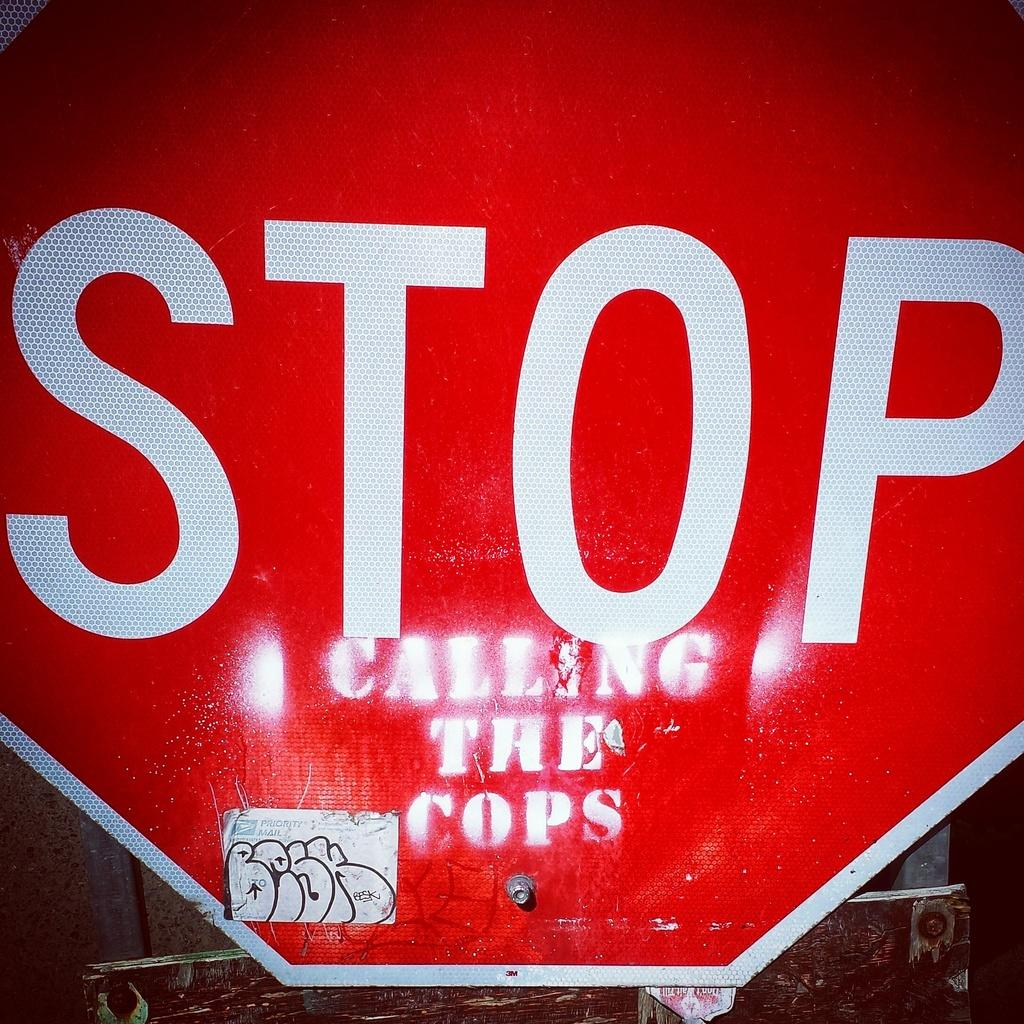<image>
Share a concise interpretation of the image provided. A stop sign has been altered with calling the cops written on it. 